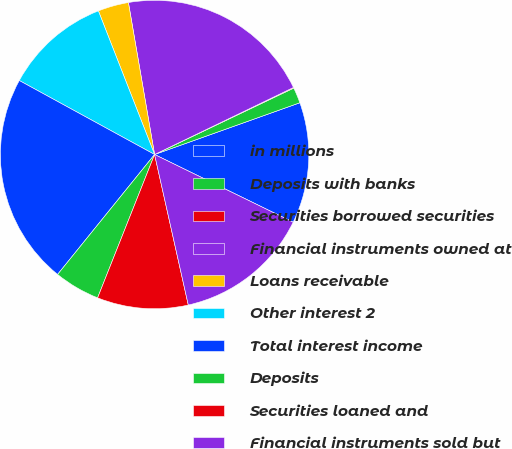Convert chart to OTSL. <chart><loc_0><loc_0><loc_500><loc_500><pie_chart><fcel>in millions<fcel>Deposits with banks<fcel>Securities borrowed securities<fcel>Financial instruments owned at<fcel>Loans receivable<fcel>Other interest 2<fcel>Total interest income<fcel>Deposits<fcel>Securities loaned and<fcel>Financial instruments sold but<nl><fcel>12.68%<fcel>1.64%<fcel>0.07%<fcel>20.56%<fcel>3.22%<fcel>11.1%<fcel>22.14%<fcel>4.8%<fcel>9.53%<fcel>14.26%<nl></chart> 